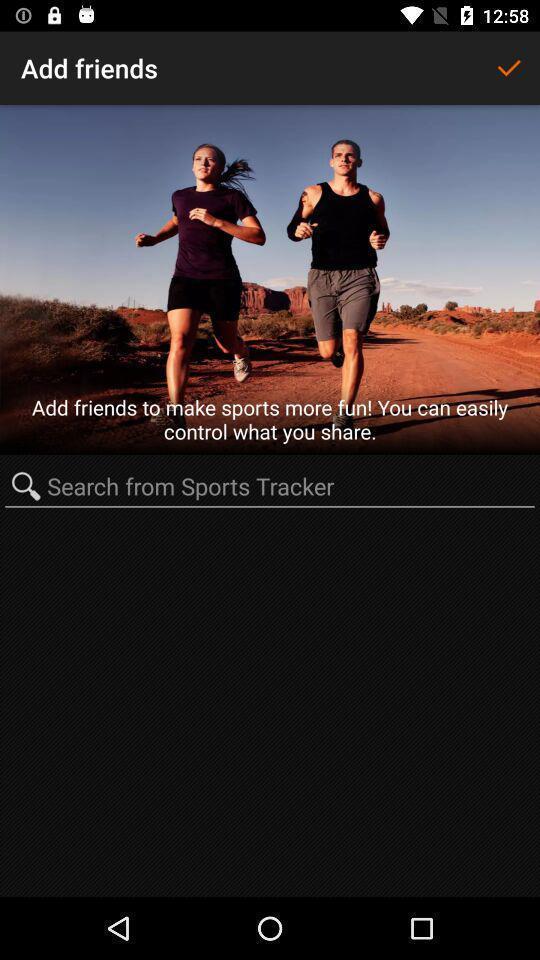What is the overall content of this screenshot? Screen shows add friends and search option in fitness app. 